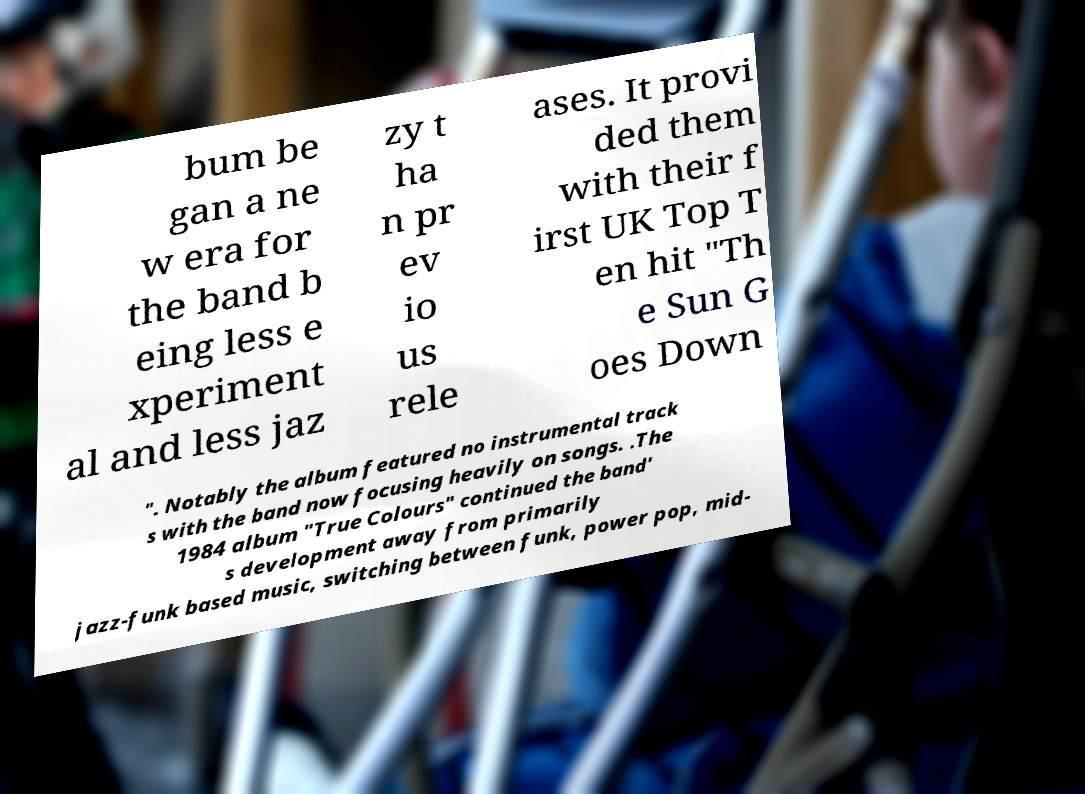Please read and relay the text visible in this image. What does it say? bum be gan a ne w era for the band b eing less e xperiment al and less jaz zy t ha n pr ev io us rele ases. It provi ded them with their f irst UK Top T en hit "Th e Sun G oes Down ". Notably the album featured no instrumental track s with the band now focusing heavily on songs. .The 1984 album "True Colours" continued the band' s development away from primarily jazz-funk based music, switching between funk, power pop, mid- 